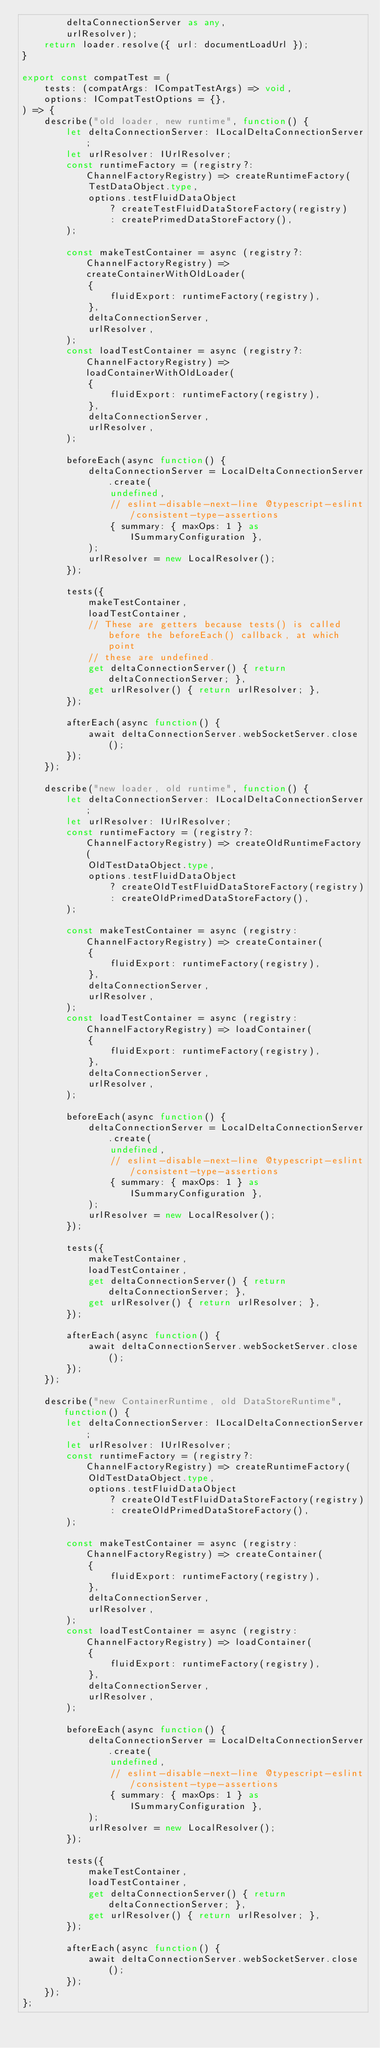Convert code to text. <code><loc_0><loc_0><loc_500><loc_500><_TypeScript_>        deltaConnectionServer as any,
        urlResolver);
    return loader.resolve({ url: documentLoadUrl });
}

export const compatTest = (
    tests: (compatArgs: ICompatTestArgs) => void,
    options: ICompatTestOptions = {},
) => {
    describe("old loader, new runtime", function() {
        let deltaConnectionServer: ILocalDeltaConnectionServer;
        let urlResolver: IUrlResolver;
        const runtimeFactory = (registry?: ChannelFactoryRegistry) => createRuntimeFactory(
            TestDataObject.type,
            options.testFluidDataObject
                ? createTestFluidDataStoreFactory(registry)
                : createPrimedDataStoreFactory(),
        );

        const makeTestContainer = async (registry?: ChannelFactoryRegistry) => createContainerWithOldLoader(
            {
                fluidExport: runtimeFactory(registry),
            },
            deltaConnectionServer,
            urlResolver,
        );
        const loadTestContainer = async (registry?: ChannelFactoryRegistry) => loadContainerWithOldLoader(
            {
                fluidExport: runtimeFactory(registry),
            },
            deltaConnectionServer,
            urlResolver,
        );

        beforeEach(async function() {
            deltaConnectionServer = LocalDeltaConnectionServer.create(
                undefined,
                // eslint-disable-next-line @typescript-eslint/consistent-type-assertions
                { summary: { maxOps: 1 } as ISummaryConfiguration },
            );
            urlResolver = new LocalResolver();
        });

        tests({
            makeTestContainer,
            loadTestContainer,
            // These are getters because tests() is called before the beforeEach() callback, at which point
            // these are undefined.
            get deltaConnectionServer() { return deltaConnectionServer; },
            get urlResolver() { return urlResolver; },
        });

        afterEach(async function() {
            await deltaConnectionServer.webSocketServer.close();
        });
    });

    describe("new loader, old runtime", function() {
        let deltaConnectionServer: ILocalDeltaConnectionServer;
        let urlResolver: IUrlResolver;
        const runtimeFactory = (registry?: ChannelFactoryRegistry) => createOldRuntimeFactory(
            OldTestDataObject.type,
            options.testFluidDataObject
                ? createOldTestFluidDataStoreFactory(registry)
                : createOldPrimedDataStoreFactory(),
        );

        const makeTestContainer = async (registry: ChannelFactoryRegistry) => createContainer(
            {
                fluidExport: runtimeFactory(registry),
            },
            deltaConnectionServer,
            urlResolver,
        );
        const loadTestContainer = async (registry: ChannelFactoryRegistry) => loadContainer(
            {
                fluidExport: runtimeFactory(registry),
            },
            deltaConnectionServer,
            urlResolver,
        );

        beforeEach(async function() {
            deltaConnectionServer = LocalDeltaConnectionServer.create(
                undefined,
                // eslint-disable-next-line @typescript-eslint/consistent-type-assertions
                { summary: { maxOps: 1 } as ISummaryConfiguration },
            );
            urlResolver = new LocalResolver();
        });

        tests({
            makeTestContainer,
            loadTestContainer,
            get deltaConnectionServer() { return deltaConnectionServer; },
            get urlResolver() { return urlResolver; },
        });

        afterEach(async function() {
            await deltaConnectionServer.webSocketServer.close();
        });
    });

    describe("new ContainerRuntime, old DataStoreRuntime", function() {
        let deltaConnectionServer: ILocalDeltaConnectionServer;
        let urlResolver: IUrlResolver;
        const runtimeFactory = (registry?: ChannelFactoryRegistry) => createRuntimeFactory(
            OldTestDataObject.type,
            options.testFluidDataObject
                ? createOldTestFluidDataStoreFactory(registry)
                : createOldPrimedDataStoreFactory(),
        );

        const makeTestContainer = async (registry: ChannelFactoryRegistry) => createContainer(
            {
                fluidExport: runtimeFactory(registry),
            },
            deltaConnectionServer,
            urlResolver,
        );
        const loadTestContainer = async (registry: ChannelFactoryRegistry) => loadContainer(
            {
                fluidExport: runtimeFactory(registry),
            },
            deltaConnectionServer,
            urlResolver,
        );

        beforeEach(async function() {
            deltaConnectionServer = LocalDeltaConnectionServer.create(
                undefined,
                // eslint-disable-next-line @typescript-eslint/consistent-type-assertions
                { summary: { maxOps: 1 } as ISummaryConfiguration },
            );
            urlResolver = new LocalResolver();
        });

        tests({
            makeTestContainer,
            loadTestContainer,
            get deltaConnectionServer() { return deltaConnectionServer; },
            get urlResolver() { return urlResolver; },
        });

        afterEach(async function() {
            await deltaConnectionServer.webSocketServer.close();
        });
    });
};
</code> 